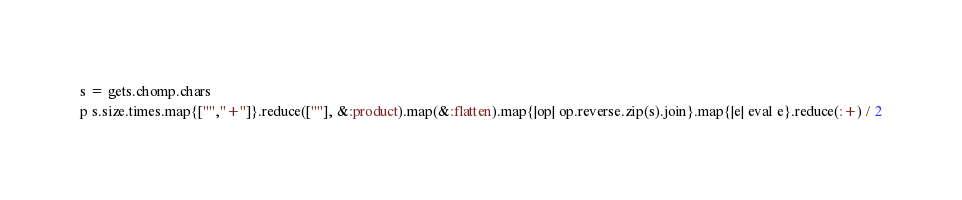Convert code to text. <code><loc_0><loc_0><loc_500><loc_500><_Ruby_>s = gets.chomp.chars
p s.size.times.map{["","+"]}.reduce([""], &:product).map(&:flatten).map{|op| op.reverse.zip(s).join}.map{|e| eval e}.reduce(:+) / 2</code> 